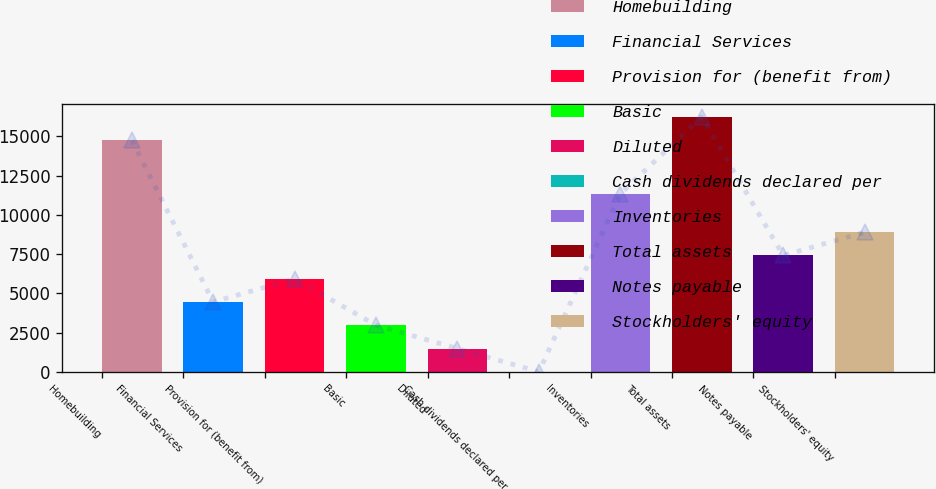Convert chart. <chart><loc_0><loc_0><loc_500><loc_500><bar_chart><fcel>Homebuilding<fcel>Financial Services<fcel>Provision for (benefit from)<fcel>Basic<fcel>Diluted<fcel>Cash dividends declared per<fcel>Inventories<fcel>Total assets<fcel>Notes payable<fcel>Stockholders' equity<nl><fcel>14760.5<fcel>4446.53<fcel>5928.56<fcel>2964.5<fcel>1482.47<fcel>0.44<fcel>11343.1<fcel>16242.5<fcel>7410.59<fcel>8892.62<nl></chart> 